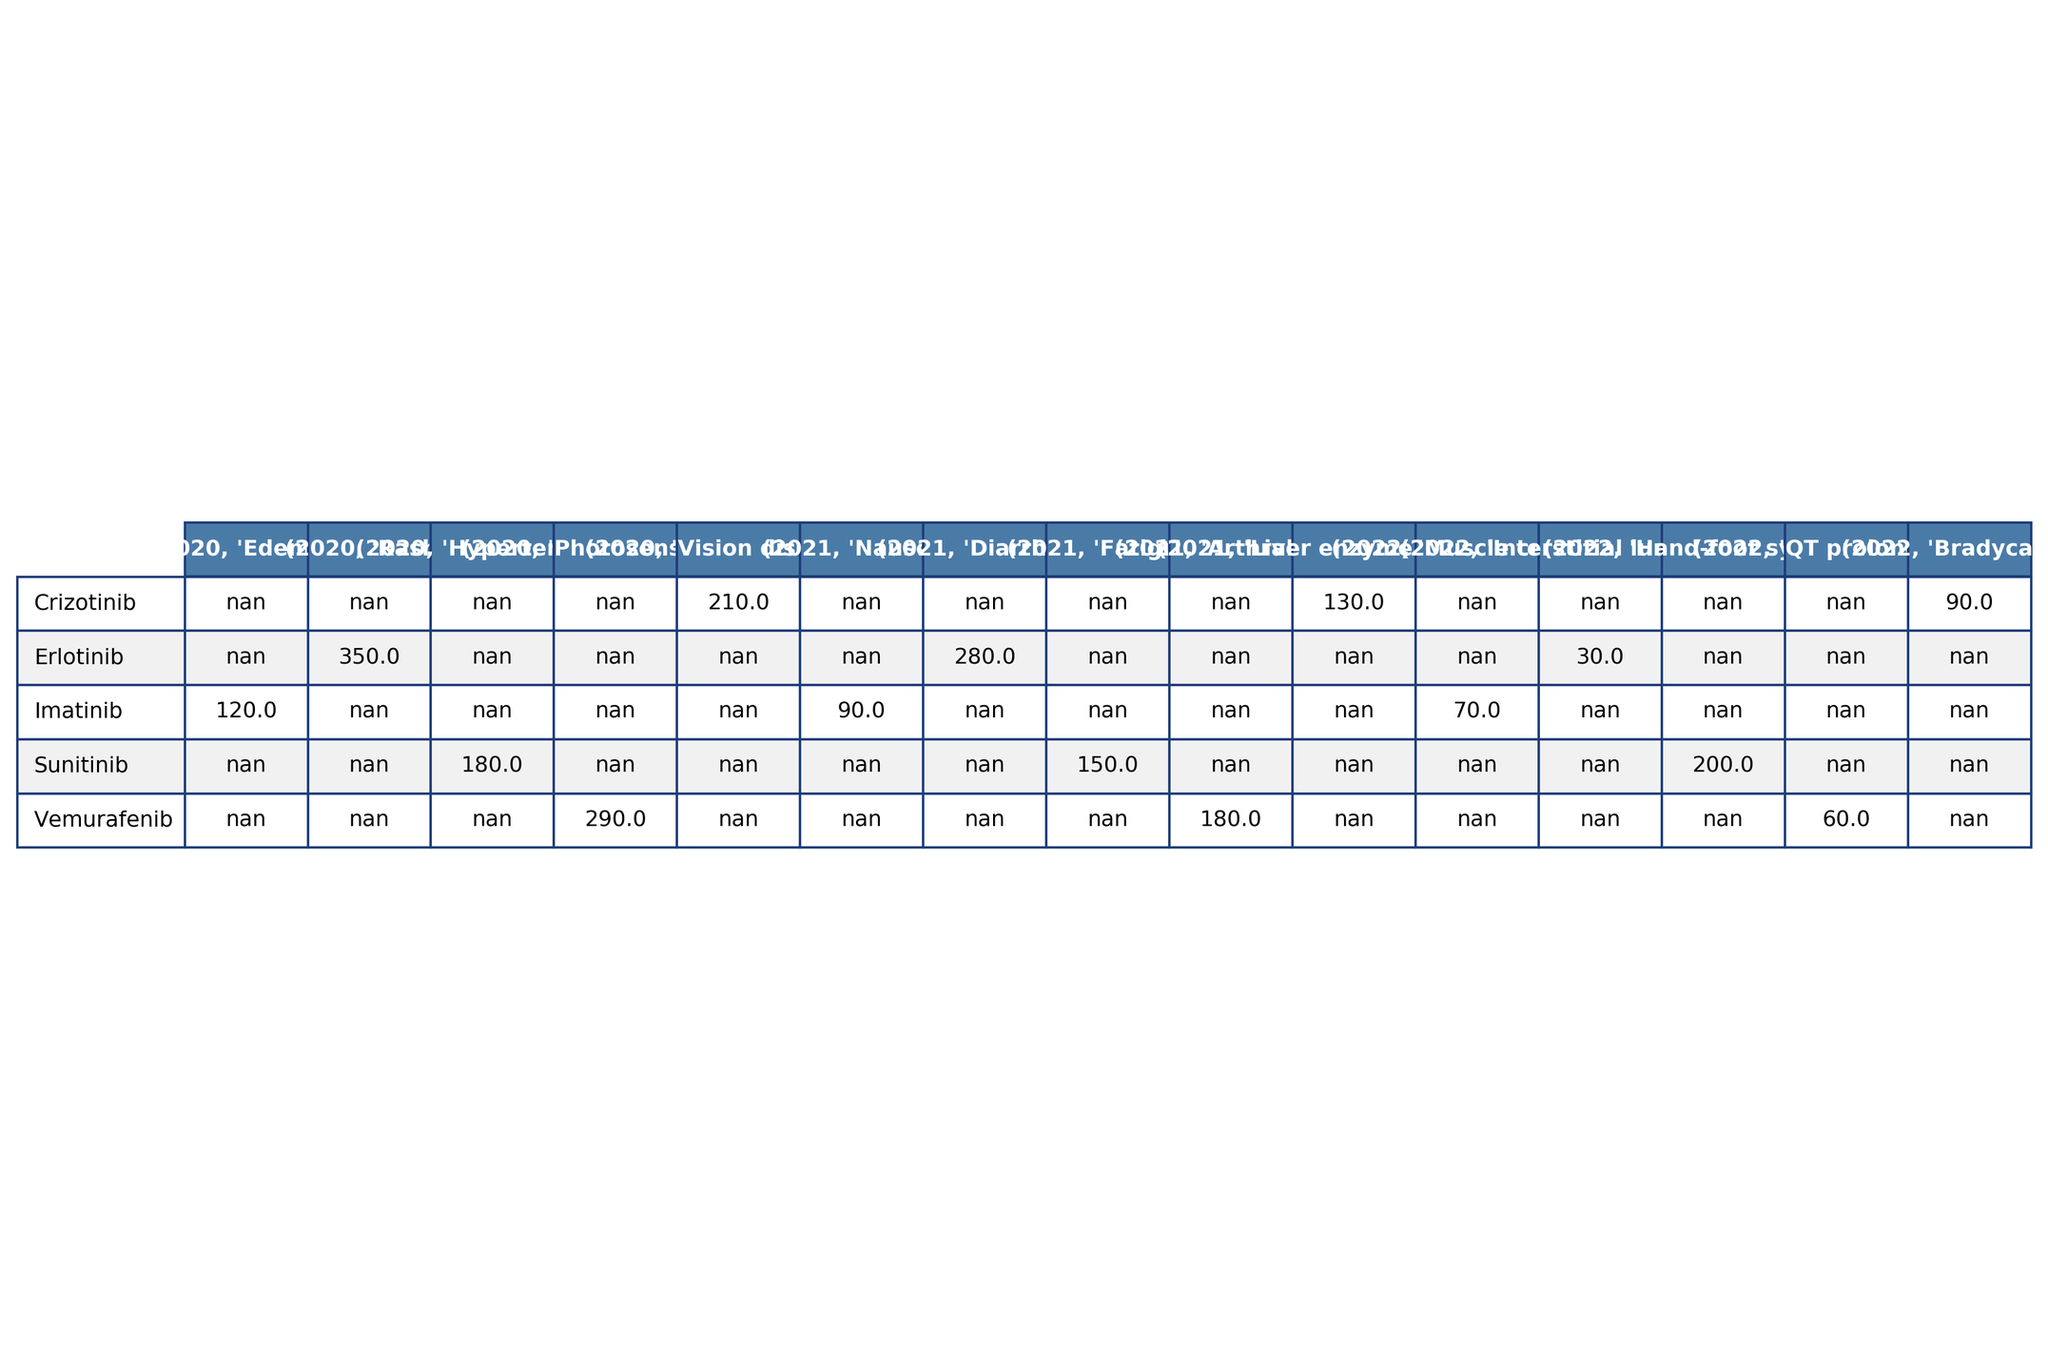What is the frequency of rash reported for Erlotinib in 2020? The table shows that for the drug Erlotinib in the year 2020, the adverse event "Rash" has a reported frequency of 350 per 1000 patients.
Answer: 350 Which drug had the highest reported frequency of adverse events in 2021? By inspecting the table for the year 2021, Sunitinib's adverse event "Fatigue" has the highest reported frequency at 150 per 1000 patients among the listed drugs and events.
Answer: 150 What is the frequency of muscle cramps for Imatinib in 2022? The table indicates that in the year 2022, the adverse event "Muscle cramps" for Imatinib had a reported frequency of 70 per 1000 patients.
Answer: 70 Did Vemurafenib report any adverse event frequency higher than 200 in 2021? Checking the frequencies for Vemurafenib in 2021, the reported frequencies for "Arthralgia" and "QT prolongation" are 180 and 60, respectively; thus, Vemurafenib did not report any frequency higher than 200 in that year.
Answer: No Which drug had more adverse events reported in 2020: Crizotinib or Sunitinib? In 2020, Crizotinib had one adverse event listed (Vision disorders at 210), and Sunitinib had one adverse event listed (Hypertension at 180). Since Crizotinib has a higher frequency for its single event (210 vs 180), Crizotinib had more adverse events reported.
Answer: Crizotinib What was the overall change in the frequency of edema for Imatinib from 2020 to 2022? For Imatinib, the frequency of edema is recorded only for 2020, at 120, with no reported frequency in 2021 or 2022. Therefore, there is effectively a decrease to 0 in subsequent years.
Answer: 120 to 0 Calculate the average frequency of adverse events for Sunitinib over the three years. The reported frequencies for Sunitinib are 180 (2020), 150 (2021), and 200 (2022). Summing these gives 180 + 150 + 200 = 530, and with three data points, the average is 530 / 3 = 176.67.
Answer: 176.67 Which drug has the lowest reported adverse event frequency in 2022? Traversing through the table for 2022, the reported frequencies are Imatinib (70), Erlotinib (30), Sunitinib (200), Vemurafenib (60), and Crizotinib (90). The lowest frequency is for Erlotinib at 30.
Answer: Erlotinib How did the frequency of diarrhea for Erlotinib change from 2020 to 2021? The table displays no diarrhea for Erlotinib in 2020, with a frequency of 280 in 2021. Therefore, there is an increase in reported frequency.
Answer: Increase Which drug had fewer adverse events reported in 2021 compared to 2020? By examining the frequencies, for Sunitinib, which had 180 in 2020 and 150 in 2021, there is a decline in reported frequency, signifying fewer events compared to the previous year.
Answer: Sunitinib 